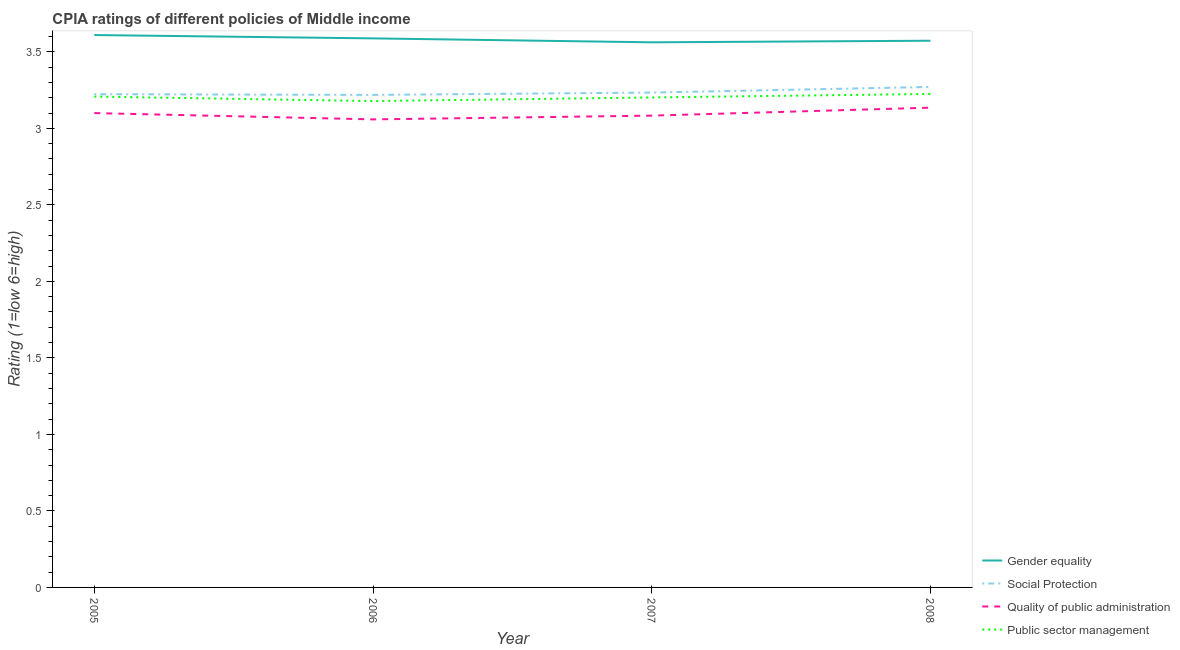Does the line corresponding to cpia rating of quality of public administration intersect with the line corresponding to cpia rating of social protection?
Your response must be concise. No. What is the cpia rating of public sector management in 2006?
Keep it short and to the point. 3.18. Across all years, what is the maximum cpia rating of quality of public administration?
Make the answer very short. 3.14. Across all years, what is the minimum cpia rating of quality of public administration?
Ensure brevity in your answer.  3.06. In which year was the cpia rating of public sector management minimum?
Your response must be concise. 2006. What is the total cpia rating of social protection in the graph?
Give a very brief answer. 12.95. What is the difference between the cpia rating of quality of public administration in 2006 and that in 2008?
Make the answer very short. -0.08. What is the difference between the cpia rating of public sector management in 2006 and the cpia rating of quality of public administration in 2005?
Your answer should be very brief. 0.08. What is the average cpia rating of public sector management per year?
Ensure brevity in your answer.  3.2. In the year 2007, what is the difference between the cpia rating of public sector management and cpia rating of quality of public administration?
Provide a succinct answer. 0.12. In how many years, is the cpia rating of quality of public administration greater than 1.1?
Make the answer very short. 4. What is the ratio of the cpia rating of social protection in 2006 to that in 2007?
Provide a short and direct response. 1. Is the difference between the cpia rating of quality of public administration in 2005 and 2008 greater than the difference between the cpia rating of social protection in 2005 and 2008?
Provide a succinct answer. Yes. What is the difference between the highest and the second highest cpia rating of public sector management?
Make the answer very short. 0.02. What is the difference between the highest and the lowest cpia rating of gender equality?
Your answer should be compact. 0.05. In how many years, is the cpia rating of public sector management greater than the average cpia rating of public sector management taken over all years?
Make the answer very short. 2. Is it the case that in every year, the sum of the cpia rating of gender equality and cpia rating of social protection is greater than the sum of cpia rating of quality of public administration and cpia rating of public sector management?
Offer a terse response. Yes. Is it the case that in every year, the sum of the cpia rating of gender equality and cpia rating of social protection is greater than the cpia rating of quality of public administration?
Offer a terse response. Yes. What is the difference between two consecutive major ticks on the Y-axis?
Give a very brief answer. 0.5. Are the values on the major ticks of Y-axis written in scientific E-notation?
Offer a terse response. No. Does the graph contain grids?
Your response must be concise. No. Where does the legend appear in the graph?
Provide a succinct answer. Bottom right. How many legend labels are there?
Provide a succinct answer. 4. What is the title of the graph?
Provide a short and direct response. CPIA ratings of different policies of Middle income. Does "Business regulatory environment" appear as one of the legend labels in the graph?
Make the answer very short. No. What is the Rating (1=low 6=high) of Gender equality in 2005?
Make the answer very short. 3.61. What is the Rating (1=low 6=high) in Social Protection in 2005?
Provide a succinct answer. 3.22. What is the Rating (1=low 6=high) in Quality of public administration in 2005?
Provide a short and direct response. 3.1. What is the Rating (1=low 6=high) of Public sector management in 2005?
Provide a succinct answer. 3.21. What is the Rating (1=low 6=high) of Gender equality in 2006?
Make the answer very short. 3.59. What is the Rating (1=low 6=high) of Social Protection in 2006?
Provide a short and direct response. 3.22. What is the Rating (1=low 6=high) in Quality of public administration in 2006?
Give a very brief answer. 3.06. What is the Rating (1=low 6=high) of Public sector management in 2006?
Keep it short and to the point. 3.18. What is the Rating (1=low 6=high) in Gender equality in 2007?
Your answer should be very brief. 3.56. What is the Rating (1=low 6=high) in Social Protection in 2007?
Your answer should be compact. 3.23. What is the Rating (1=low 6=high) of Quality of public administration in 2007?
Give a very brief answer. 3.08. What is the Rating (1=low 6=high) of Public sector management in 2007?
Make the answer very short. 3.2. What is the Rating (1=low 6=high) in Gender equality in 2008?
Make the answer very short. 3.57. What is the Rating (1=low 6=high) in Social Protection in 2008?
Provide a succinct answer. 3.27. What is the Rating (1=low 6=high) of Quality of public administration in 2008?
Provide a short and direct response. 3.14. What is the Rating (1=low 6=high) of Public sector management in 2008?
Ensure brevity in your answer.  3.23. Across all years, what is the maximum Rating (1=low 6=high) of Gender equality?
Offer a terse response. 3.61. Across all years, what is the maximum Rating (1=low 6=high) of Social Protection?
Provide a succinct answer. 3.27. Across all years, what is the maximum Rating (1=low 6=high) of Quality of public administration?
Keep it short and to the point. 3.14. Across all years, what is the maximum Rating (1=low 6=high) of Public sector management?
Provide a short and direct response. 3.23. Across all years, what is the minimum Rating (1=low 6=high) in Gender equality?
Offer a very short reply. 3.56. Across all years, what is the minimum Rating (1=low 6=high) in Social Protection?
Provide a short and direct response. 3.22. Across all years, what is the minimum Rating (1=low 6=high) of Quality of public administration?
Provide a succinct answer. 3.06. Across all years, what is the minimum Rating (1=low 6=high) in Public sector management?
Your answer should be very brief. 3.18. What is the total Rating (1=low 6=high) of Gender equality in the graph?
Your answer should be compact. 14.33. What is the total Rating (1=low 6=high) of Social Protection in the graph?
Give a very brief answer. 12.95. What is the total Rating (1=low 6=high) in Quality of public administration in the graph?
Provide a short and direct response. 12.38. What is the total Rating (1=low 6=high) in Public sector management in the graph?
Offer a terse response. 12.81. What is the difference between the Rating (1=low 6=high) in Gender equality in 2005 and that in 2006?
Your response must be concise. 0.02. What is the difference between the Rating (1=low 6=high) of Social Protection in 2005 and that in 2006?
Give a very brief answer. 0. What is the difference between the Rating (1=low 6=high) of Quality of public administration in 2005 and that in 2006?
Give a very brief answer. 0.04. What is the difference between the Rating (1=low 6=high) in Public sector management in 2005 and that in 2006?
Give a very brief answer. 0.03. What is the difference between the Rating (1=low 6=high) of Gender equality in 2005 and that in 2007?
Give a very brief answer. 0.05. What is the difference between the Rating (1=low 6=high) of Social Protection in 2005 and that in 2007?
Your response must be concise. -0.01. What is the difference between the Rating (1=low 6=high) in Quality of public administration in 2005 and that in 2007?
Provide a short and direct response. 0.02. What is the difference between the Rating (1=low 6=high) in Public sector management in 2005 and that in 2007?
Make the answer very short. 0.01. What is the difference between the Rating (1=low 6=high) of Gender equality in 2005 and that in 2008?
Offer a terse response. 0.04. What is the difference between the Rating (1=low 6=high) in Social Protection in 2005 and that in 2008?
Offer a very short reply. -0.05. What is the difference between the Rating (1=low 6=high) of Quality of public administration in 2005 and that in 2008?
Your answer should be compact. -0.04. What is the difference between the Rating (1=low 6=high) of Public sector management in 2005 and that in 2008?
Ensure brevity in your answer.  -0.02. What is the difference between the Rating (1=low 6=high) in Gender equality in 2006 and that in 2007?
Keep it short and to the point. 0.03. What is the difference between the Rating (1=low 6=high) of Social Protection in 2006 and that in 2007?
Your answer should be compact. -0.02. What is the difference between the Rating (1=low 6=high) of Quality of public administration in 2006 and that in 2007?
Give a very brief answer. -0.02. What is the difference between the Rating (1=low 6=high) of Public sector management in 2006 and that in 2007?
Keep it short and to the point. -0.02. What is the difference between the Rating (1=low 6=high) in Gender equality in 2006 and that in 2008?
Offer a very short reply. 0.02. What is the difference between the Rating (1=low 6=high) in Social Protection in 2006 and that in 2008?
Offer a very short reply. -0.05. What is the difference between the Rating (1=low 6=high) of Quality of public administration in 2006 and that in 2008?
Ensure brevity in your answer.  -0.08. What is the difference between the Rating (1=low 6=high) of Public sector management in 2006 and that in 2008?
Keep it short and to the point. -0.05. What is the difference between the Rating (1=low 6=high) in Gender equality in 2007 and that in 2008?
Provide a succinct answer. -0.01. What is the difference between the Rating (1=low 6=high) of Social Protection in 2007 and that in 2008?
Provide a short and direct response. -0.04. What is the difference between the Rating (1=low 6=high) of Quality of public administration in 2007 and that in 2008?
Ensure brevity in your answer.  -0.05. What is the difference between the Rating (1=low 6=high) in Public sector management in 2007 and that in 2008?
Your answer should be very brief. -0.02. What is the difference between the Rating (1=low 6=high) in Gender equality in 2005 and the Rating (1=low 6=high) in Social Protection in 2006?
Offer a very short reply. 0.39. What is the difference between the Rating (1=low 6=high) of Gender equality in 2005 and the Rating (1=low 6=high) of Quality of public administration in 2006?
Offer a very short reply. 0.55. What is the difference between the Rating (1=low 6=high) in Gender equality in 2005 and the Rating (1=low 6=high) in Public sector management in 2006?
Ensure brevity in your answer.  0.43. What is the difference between the Rating (1=low 6=high) of Social Protection in 2005 and the Rating (1=low 6=high) of Quality of public administration in 2006?
Keep it short and to the point. 0.16. What is the difference between the Rating (1=low 6=high) of Social Protection in 2005 and the Rating (1=low 6=high) of Public sector management in 2006?
Ensure brevity in your answer.  0.04. What is the difference between the Rating (1=low 6=high) in Quality of public administration in 2005 and the Rating (1=low 6=high) in Public sector management in 2006?
Your answer should be compact. -0.08. What is the difference between the Rating (1=low 6=high) in Gender equality in 2005 and the Rating (1=low 6=high) in Social Protection in 2007?
Offer a very short reply. 0.38. What is the difference between the Rating (1=low 6=high) of Gender equality in 2005 and the Rating (1=low 6=high) of Quality of public administration in 2007?
Keep it short and to the point. 0.53. What is the difference between the Rating (1=low 6=high) of Gender equality in 2005 and the Rating (1=low 6=high) of Public sector management in 2007?
Your answer should be very brief. 0.41. What is the difference between the Rating (1=low 6=high) in Social Protection in 2005 and the Rating (1=low 6=high) in Quality of public administration in 2007?
Provide a succinct answer. 0.14. What is the difference between the Rating (1=low 6=high) in Social Protection in 2005 and the Rating (1=low 6=high) in Public sector management in 2007?
Provide a succinct answer. 0.02. What is the difference between the Rating (1=low 6=high) in Quality of public administration in 2005 and the Rating (1=low 6=high) in Public sector management in 2007?
Your answer should be compact. -0.1. What is the difference between the Rating (1=low 6=high) of Gender equality in 2005 and the Rating (1=low 6=high) of Social Protection in 2008?
Your answer should be compact. 0.34. What is the difference between the Rating (1=low 6=high) in Gender equality in 2005 and the Rating (1=low 6=high) in Quality of public administration in 2008?
Offer a terse response. 0.47. What is the difference between the Rating (1=low 6=high) in Gender equality in 2005 and the Rating (1=low 6=high) in Public sector management in 2008?
Your answer should be very brief. 0.39. What is the difference between the Rating (1=low 6=high) in Social Protection in 2005 and the Rating (1=low 6=high) in Quality of public administration in 2008?
Provide a short and direct response. 0.09. What is the difference between the Rating (1=low 6=high) in Social Protection in 2005 and the Rating (1=low 6=high) in Public sector management in 2008?
Your response must be concise. -0. What is the difference between the Rating (1=low 6=high) of Quality of public administration in 2005 and the Rating (1=low 6=high) of Public sector management in 2008?
Ensure brevity in your answer.  -0.12. What is the difference between the Rating (1=low 6=high) of Gender equality in 2006 and the Rating (1=low 6=high) of Social Protection in 2007?
Make the answer very short. 0.35. What is the difference between the Rating (1=low 6=high) of Gender equality in 2006 and the Rating (1=low 6=high) of Quality of public administration in 2007?
Provide a succinct answer. 0.5. What is the difference between the Rating (1=low 6=high) in Gender equality in 2006 and the Rating (1=low 6=high) in Public sector management in 2007?
Keep it short and to the point. 0.39. What is the difference between the Rating (1=low 6=high) of Social Protection in 2006 and the Rating (1=low 6=high) of Quality of public administration in 2007?
Provide a succinct answer. 0.14. What is the difference between the Rating (1=low 6=high) in Social Protection in 2006 and the Rating (1=low 6=high) in Public sector management in 2007?
Keep it short and to the point. 0.02. What is the difference between the Rating (1=low 6=high) of Quality of public administration in 2006 and the Rating (1=low 6=high) of Public sector management in 2007?
Offer a very short reply. -0.14. What is the difference between the Rating (1=low 6=high) of Gender equality in 2006 and the Rating (1=low 6=high) of Social Protection in 2008?
Make the answer very short. 0.32. What is the difference between the Rating (1=low 6=high) in Gender equality in 2006 and the Rating (1=low 6=high) in Quality of public administration in 2008?
Offer a terse response. 0.45. What is the difference between the Rating (1=low 6=high) in Gender equality in 2006 and the Rating (1=low 6=high) in Public sector management in 2008?
Provide a succinct answer. 0.36. What is the difference between the Rating (1=low 6=high) in Social Protection in 2006 and the Rating (1=low 6=high) in Quality of public administration in 2008?
Your response must be concise. 0.08. What is the difference between the Rating (1=low 6=high) in Social Protection in 2006 and the Rating (1=low 6=high) in Public sector management in 2008?
Provide a succinct answer. -0.01. What is the difference between the Rating (1=low 6=high) of Quality of public administration in 2006 and the Rating (1=low 6=high) of Public sector management in 2008?
Your answer should be very brief. -0.17. What is the difference between the Rating (1=low 6=high) in Gender equality in 2007 and the Rating (1=low 6=high) in Social Protection in 2008?
Ensure brevity in your answer.  0.29. What is the difference between the Rating (1=low 6=high) in Gender equality in 2007 and the Rating (1=low 6=high) in Quality of public administration in 2008?
Keep it short and to the point. 0.43. What is the difference between the Rating (1=low 6=high) in Gender equality in 2007 and the Rating (1=low 6=high) in Public sector management in 2008?
Your response must be concise. 0.34. What is the difference between the Rating (1=low 6=high) in Social Protection in 2007 and the Rating (1=low 6=high) in Quality of public administration in 2008?
Give a very brief answer. 0.1. What is the difference between the Rating (1=low 6=high) in Social Protection in 2007 and the Rating (1=low 6=high) in Public sector management in 2008?
Your response must be concise. 0.01. What is the difference between the Rating (1=low 6=high) of Quality of public administration in 2007 and the Rating (1=low 6=high) of Public sector management in 2008?
Make the answer very short. -0.14. What is the average Rating (1=low 6=high) in Gender equality per year?
Ensure brevity in your answer.  3.58. What is the average Rating (1=low 6=high) of Social Protection per year?
Offer a terse response. 3.24. What is the average Rating (1=low 6=high) of Quality of public administration per year?
Your response must be concise. 3.09. What is the average Rating (1=low 6=high) of Public sector management per year?
Make the answer very short. 3.2. In the year 2005, what is the difference between the Rating (1=low 6=high) in Gender equality and Rating (1=low 6=high) in Social Protection?
Your response must be concise. 0.39. In the year 2005, what is the difference between the Rating (1=low 6=high) in Gender equality and Rating (1=low 6=high) in Quality of public administration?
Offer a terse response. 0.51. In the year 2005, what is the difference between the Rating (1=low 6=high) in Gender equality and Rating (1=low 6=high) in Public sector management?
Offer a terse response. 0.4. In the year 2005, what is the difference between the Rating (1=low 6=high) in Social Protection and Rating (1=low 6=high) in Quality of public administration?
Make the answer very short. 0.12. In the year 2005, what is the difference between the Rating (1=low 6=high) of Social Protection and Rating (1=low 6=high) of Public sector management?
Provide a succinct answer. 0.02. In the year 2005, what is the difference between the Rating (1=low 6=high) in Quality of public administration and Rating (1=low 6=high) in Public sector management?
Keep it short and to the point. -0.11. In the year 2006, what is the difference between the Rating (1=low 6=high) of Gender equality and Rating (1=low 6=high) of Social Protection?
Offer a terse response. 0.37. In the year 2006, what is the difference between the Rating (1=low 6=high) in Gender equality and Rating (1=low 6=high) in Quality of public administration?
Keep it short and to the point. 0.53. In the year 2006, what is the difference between the Rating (1=low 6=high) in Gender equality and Rating (1=low 6=high) in Public sector management?
Ensure brevity in your answer.  0.41. In the year 2006, what is the difference between the Rating (1=low 6=high) in Social Protection and Rating (1=low 6=high) in Quality of public administration?
Provide a short and direct response. 0.16. In the year 2006, what is the difference between the Rating (1=low 6=high) of Social Protection and Rating (1=low 6=high) of Public sector management?
Keep it short and to the point. 0.04. In the year 2006, what is the difference between the Rating (1=low 6=high) in Quality of public administration and Rating (1=low 6=high) in Public sector management?
Give a very brief answer. -0.12. In the year 2007, what is the difference between the Rating (1=low 6=high) in Gender equality and Rating (1=low 6=high) in Social Protection?
Your response must be concise. 0.33. In the year 2007, what is the difference between the Rating (1=low 6=high) of Gender equality and Rating (1=low 6=high) of Quality of public administration?
Make the answer very short. 0.48. In the year 2007, what is the difference between the Rating (1=low 6=high) in Gender equality and Rating (1=low 6=high) in Public sector management?
Provide a short and direct response. 0.36. In the year 2007, what is the difference between the Rating (1=low 6=high) in Social Protection and Rating (1=low 6=high) in Quality of public administration?
Offer a very short reply. 0.15. In the year 2007, what is the difference between the Rating (1=low 6=high) of Social Protection and Rating (1=low 6=high) of Public sector management?
Keep it short and to the point. 0.03. In the year 2007, what is the difference between the Rating (1=low 6=high) in Quality of public administration and Rating (1=low 6=high) in Public sector management?
Offer a terse response. -0.12. In the year 2008, what is the difference between the Rating (1=low 6=high) of Gender equality and Rating (1=low 6=high) of Social Protection?
Your response must be concise. 0.3. In the year 2008, what is the difference between the Rating (1=low 6=high) of Gender equality and Rating (1=low 6=high) of Quality of public administration?
Your answer should be compact. 0.44. In the year 2008, what is the difference between the Rating (1=low 6=high) in Gender equality and Rating (1=low 6=high) in Public sector management?
Provide a succinct answer. 0.35. In the year 2008, what is the difference between the Rating (1=low 6=high) of Social Protection and Rating (1=low 6=high) of Quality of public administration?
Make the answer very short. 0.14. In the year 2008, what is the difference between the Rating (1=low 6=high) of Social Protection and Rating (1=low 6=high) of Public sector management?
Keep it short and to the point. 0.05. In the year 2008, what is the difference between the Rating (1=low 6=high) of Quality of public administration and Rating (1=low 6=high) of Public sector management?
Your response must be concise. -0.09. What is the ratio of the Rating (1=low 6=high) of Gender equality in 2005 to that in 2006?
Give a very brief answer. 1.01. What is the ratio of the Rating (1=low 6=high) of Social Protection in 2005 to that in 2006?
Make the answer very short. 1. What is the ratio of the Rating (1=low 6=high) of Quality of public administration in 2005 to that in 2006?
Keep it short and to the point. 1.01. What is the ratio of the Rating (1=low 6=high) in Public sector management in 2005 to that in 2006?
Offer a very short reply. 1.01. What is the ratio of the Rating (1=low 6=high) in Gender equality in 2005 to that in 2007?
Your answer should be compact. 1.01. What is the ratio of the Rating (1=low 6=high) in Social Protection in 2005 to that in 2007?
Provide a succinct answer. 1. What is the ratio of the Rating (1=low 6=high) of Quality of public administration in 2005 to that in 2007?
Offer a terse response. 1.01. What is the ratio of the Rating (1=low 6=high) of Public sector management in 2005 to that in 2007?
Keep it short and to the point. 1. What is the ratio of the Rating (1=low 6=high) in Gender equality in 2005 to that in 2008?
Provide a short and direct response. 1.01. What is the ratio of the Rating (1=low 6=high) of Social Protection in 2005 to that in 2008?
Provide a succinct answer. 0.99. What is the ratio of the Rating (1=low 6=high) of Quality of public administration in 2005 to that in 2008?
Your response must be concise. 0.99. What is the ratio of the Rating (1=low 6=high) in Gender equality in 2006 to that in 2007?
Offer a terse response. 1.01. What is the ratio of the Rating (1=low 6=high) of Social Protection in 2006 to that in 2007?
Make the answer very short. 1. What is the ratio of the Rating (1=low 6=high) of Quality of public administration in 2006 to that in 2007?
Ensure brevity in your answer.  0.99. What is the ratio of the Rating (1=low 6=high) in Gender equality in 2006 to that in 2008?
Provide a short and direct response. 1. What is the ratio of the Rating (1=low 6=high) of Social Protection in 2006 to that in 2008?
Your answer should be very brief. 0.98. What is the ratio of the Rating (1=low 6=high) in Quality of public administration in 2006 to that in 2008?
Provide a succinct answer. 0.98. What is the ratio of the Rating (1=low 6=high) in Public sector management in 2006 to that in 2008?
Ensure brevity in your answer.  0.99. What is the ratio of the Rating (1=low 6=high) in Gender equality in 2007 to that in 2008?
Your response must be concise. 1. What is the ratio of the Rating (1=low 6=high) in Social Protection in 2007 to that in 2008?
Your response must be concise. 0.99. What is the ratio of the Rating (1=low 6=high) of Quality of public administration in 2007 to that in 2008?
Make the answer very short. 0.98. What is the ratio of the Rating (1=low 6=high) in Public sector management in 2007 to that in 2008?
Your answer should be very brief. 0.99. What is the difference between the highest and the second highest Rating (1=low 6=high) in Gender equality?
Provide a succinct answer. 0.02. What is the difference between the highest and the second highest Rating (1=low 6=high) of Social Protection?
Provide a short and direct response. 0.04. What is the difference between the highest and the second highest Rating (1=low 6=high) in Quality of public administration?
Give a very brief answer. 0.04. What is the difference between the highest and the second highest Rating (1=low 6=high) in Public sector management?
Your answer should be compact. 0.02. What is the difference between the highest and the lowest Rating (1=low 6=high) of Gender equality?
Make the answer very short. 0.05. What is the difference between the highest and the lowest Rating (1=low 6=high) of Social Protection?
Provide a short and direct response. 0.05. What is the difference between the highest and the lowest Rating (1=low 6=high) of Quality of public administration?
Make the answer very short. 0.08. What is the difference between the highest and the lowest Rating (1=low 6=high) of Public sector management?
Give a very brief answer. 0.05. 